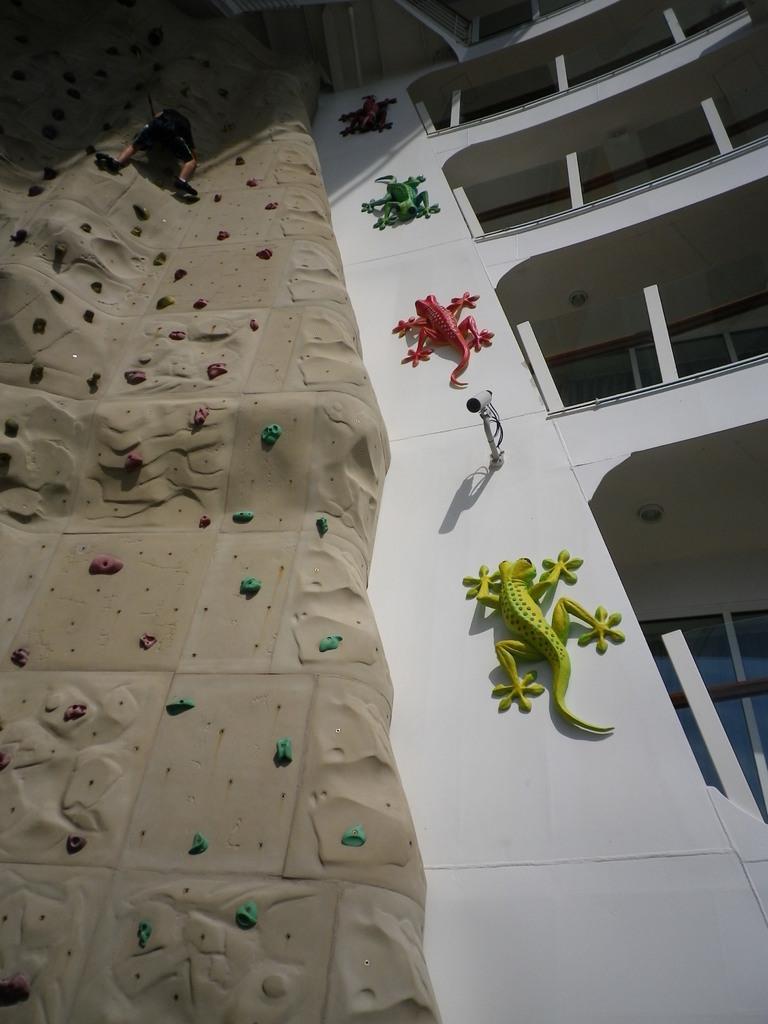How would you summarize this image in a sentence or two? In this image in front there are depictions of lizards on the wall. There is a CCTV camera. On the right side of the image there are glass windows and there is a metal fence. On the left side of the image there is a person trekking the wall. 